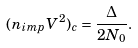<formula> <loc_0><loc_0><loc_500><loc_500>( n _ { i m p } V ^ { 2 } ) _ { c } = \frac { \Delta } { 2 N _ { 0 } } .</formula> 